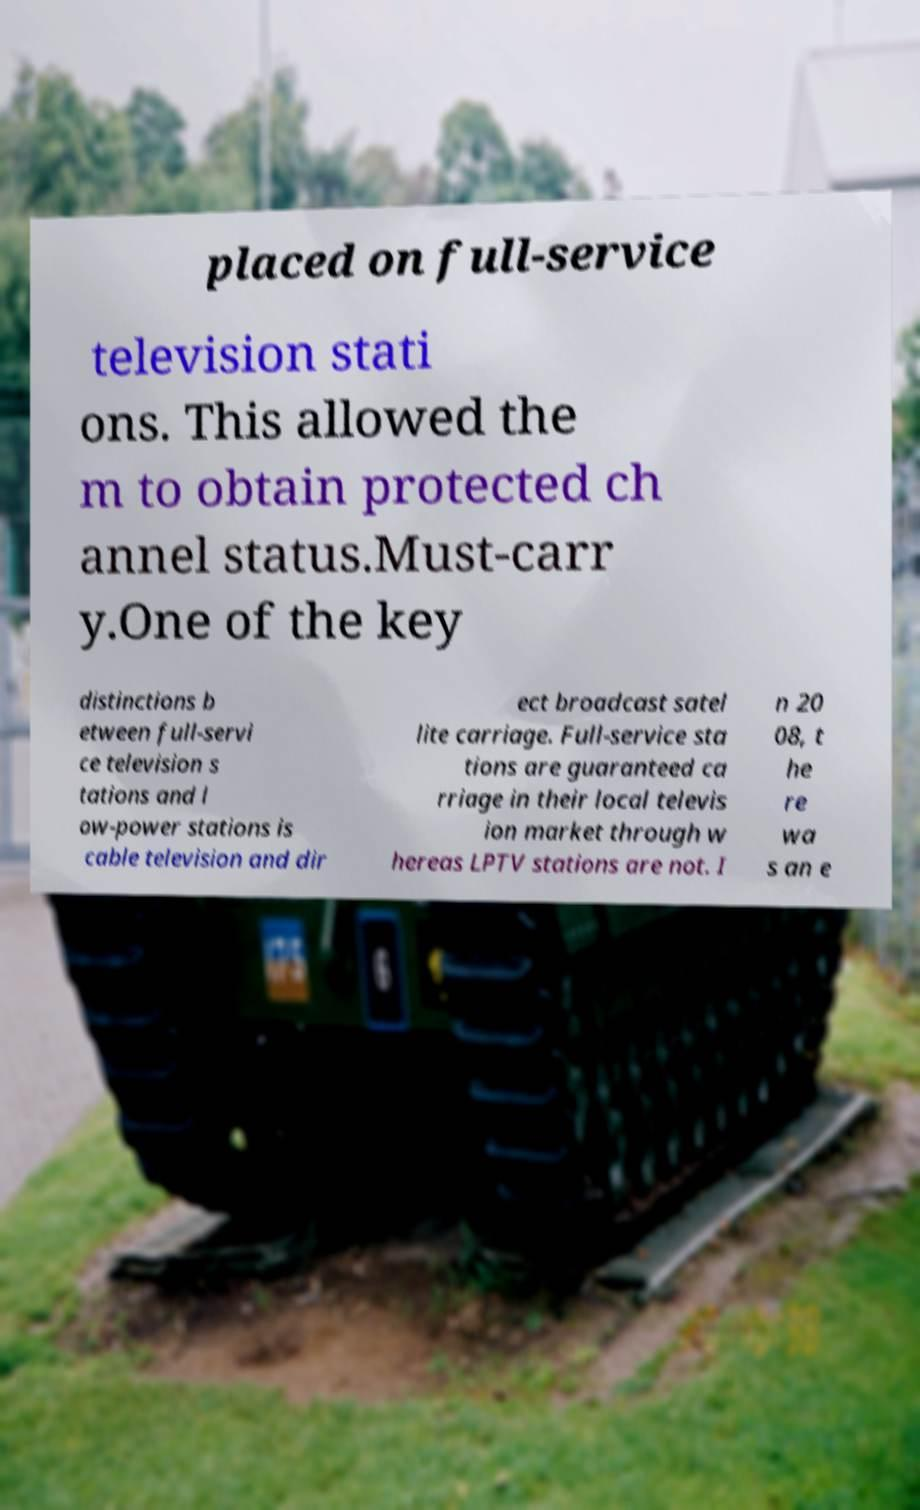Can you read and provide the text displayed in the image?This photo seems to have some interesting text. Can you extract and type it out for me? placed on full-service television stati ons. This allowed the m to obtain protected ch annel status.Must-carr y.One of the key distinctions b etween full-servi ce television s tations and l ow-power stations is cable television and dir ect broadcast satel lite carriage. Full-service sta tions are guaranteed ca rriage in their local televis ion market through w hereas LPTV stations are not. I n 20 08, t he re wa s an e 